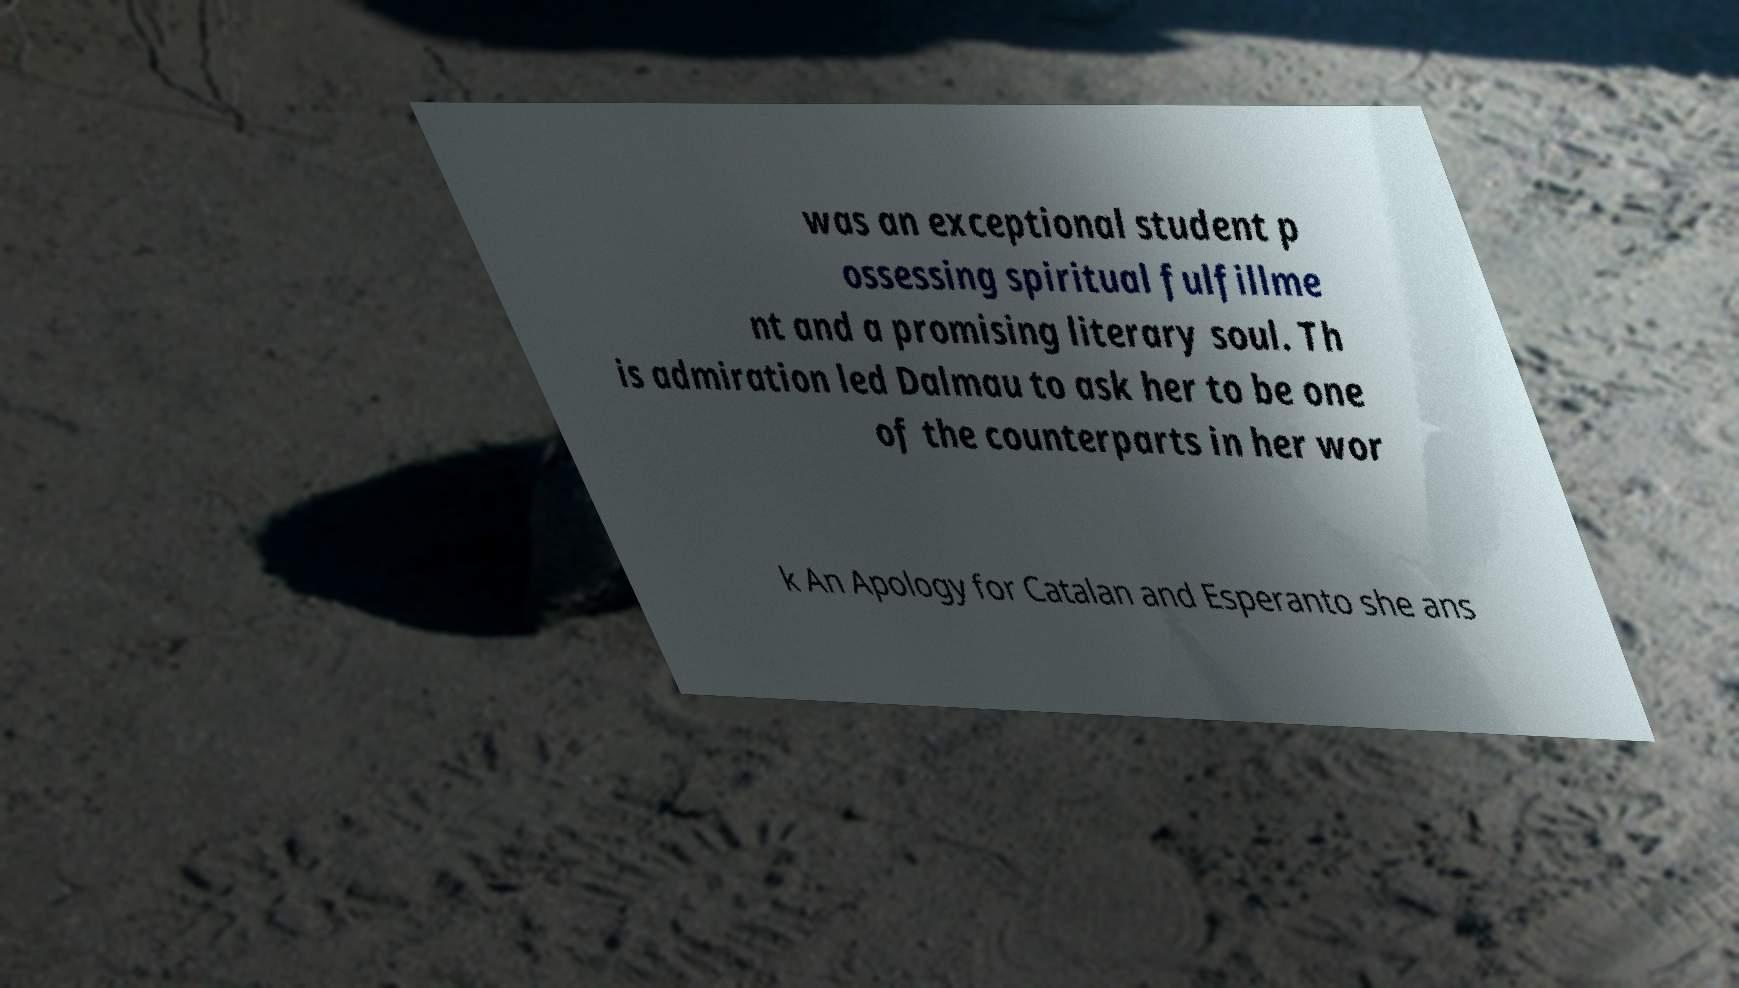Please identify and transcribe the text found in this image. was an exceptional student p ossessing spiritual fulfillme nt and a promising literary soul. Th is admiration led Dalmau to ask her to be one of the counterparts in her wor k An Apology for Catalan and Esperanto she ans 